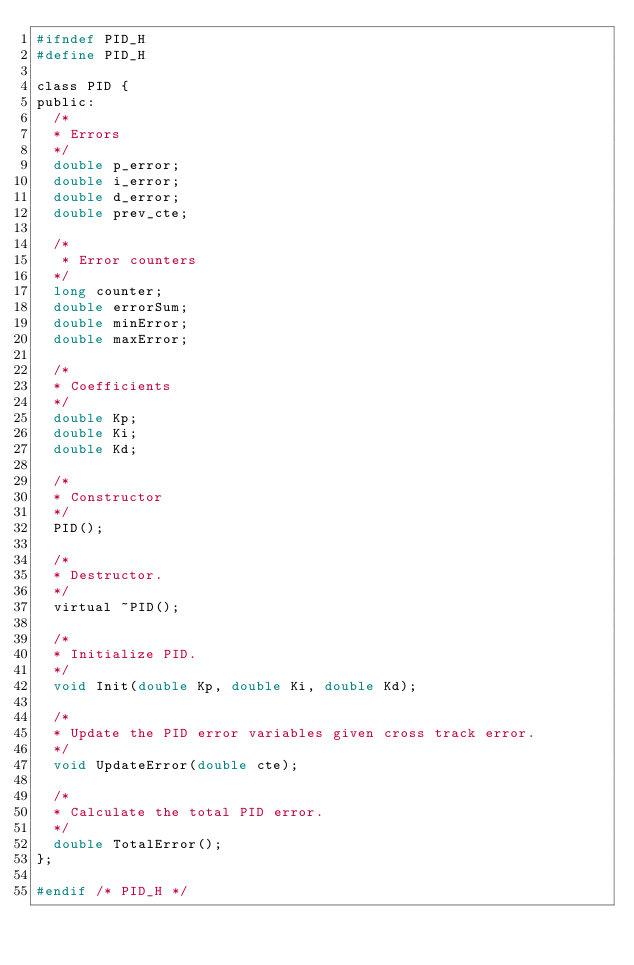Convert code to text. <code><loc_0><loc_0><loc_500><loc_500><_C_>#ifndef PID_H
#define PID_H

class PID {
public:
  /*
  * Errors
  */
  double p_error;
  double i_error;
  double d_error;
  double prev_cte;

  /*
   * Error counters
  */
  long counter;
  double errorSum;
  double minError;
  double maxError;

  /*
  * Coefficients
  */ 
  double Kp;
  double Ki;
  double Kd;

  /*
  * Constructor
  */
  PID();

  /*
  * Destructor.
  */
  virtual ~PID();

  /*
  * Initialize PID.
  */
  void Init(double Kp, double Ki, double Kd);

  /*
  * Update the PID error variables given cross track error.
  */
  void UpdateError(double cte);

  /*
  * Calculate the total PID error.
  */
  double TotalError();
};

#endif /* PID_H */
</code> 